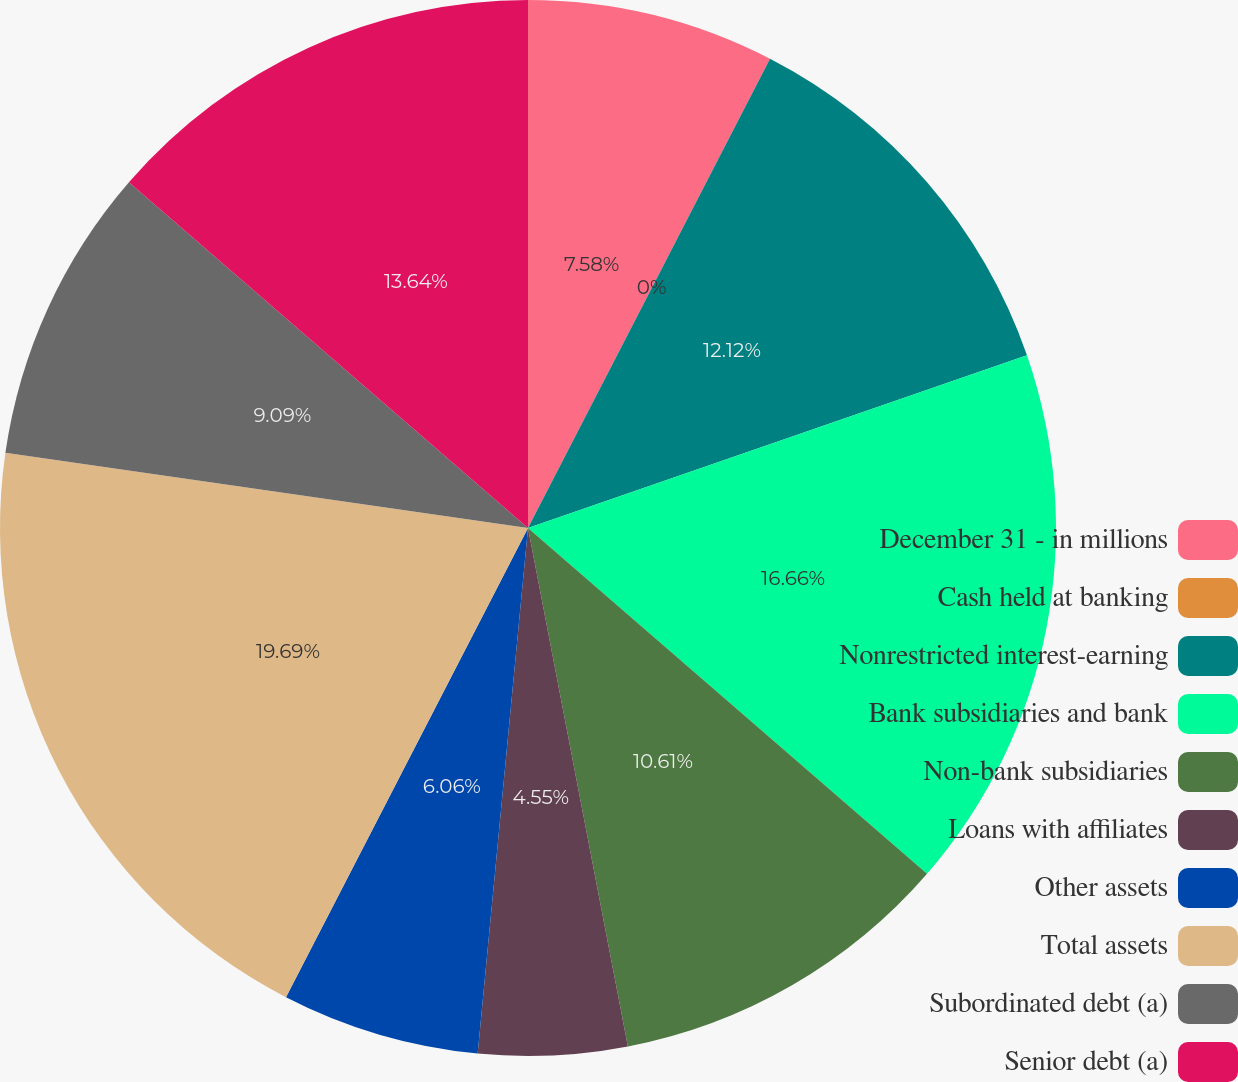<chart> <loc_0><loc_0><loc_500><loc_500><pie_chart><fcel>December 31 - in millions<fcel>Cash held at banking<fcel>Nonrestricted interest-earning<fcel>Bank subsidiaries and bank<fcel>Non-bank subsidiaries<fcel>Loans with affiliates<fcel>Other assets<fcel>Total assets<fcel>Subordinated debt (a)<fcel>Senior debt (a)<nl><fcel>7.58%<fcel>0.0%<fcel>12.12%<fcel>16.67%<fcel>10.61%<fcel>4.55%<fcel>6.06%<fcel>19.7%<fcel>9.09%<fcel>13.64%<nl></chart> 